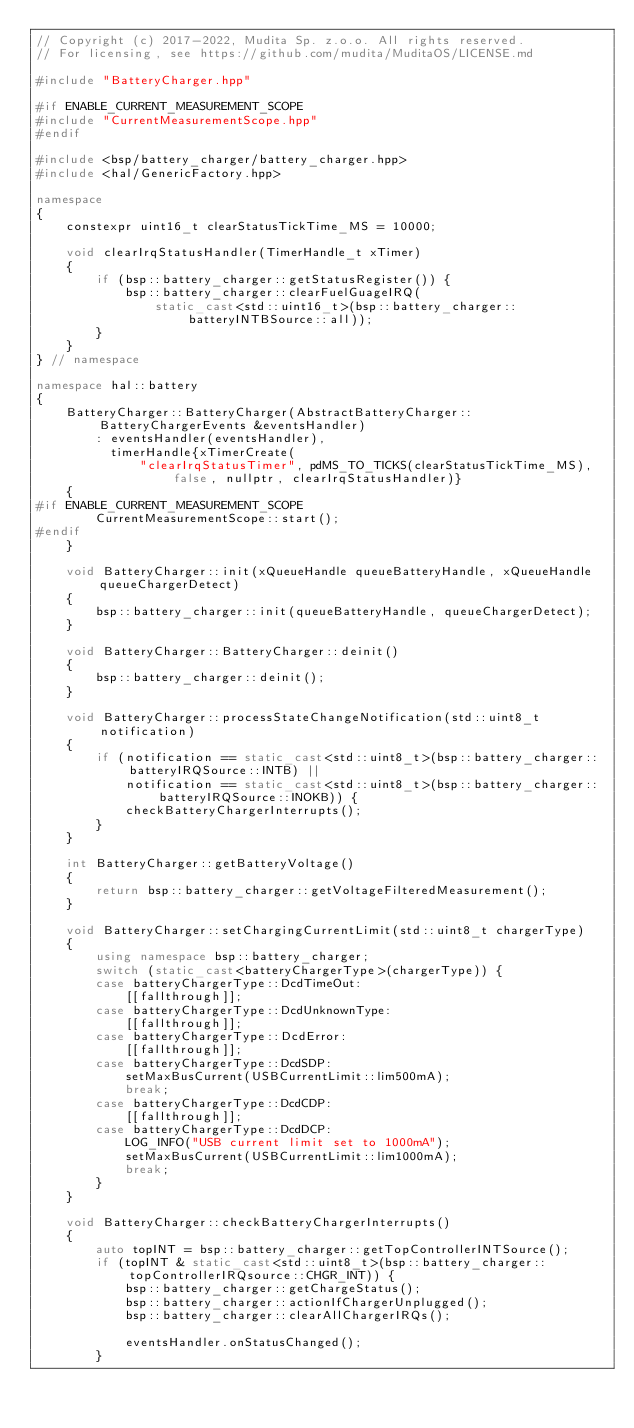Convert code to text. <code><loc_0><loc_0><loc_500><loc_500><_C++_>// Copyright (c) 2017-2022, Mudita Sp. z.o.o. All rights reserved.
// For licensing, see https://github.com/mudita/MuditaOS/LICENSE.md

#include "BatteryCharger.hpp"

#if ENABLE_CURRENT_MEASUREMENT_SCOPE
#include "CurrentMeasurementScope.hpp"
#endif

#include <bsp/battery_charger/battery_charger.hpp>
#include <hal/GenericFactory.hpp>

namespace
{
    constexpr uint16_t clearStatusTickTime_MS = 10000;

    void clearIrqStatusHandler(TimerHandle_t xTimer)
    {
        if (bsp::battery_charger::getStatusRegister()) {
            bsp::battery_charger::clearFuelGuageIRQ(
                static_cast<std::uint16_t>(bsp::battery_charger::batteryINTBSource::all));
        }
    }
} // namespace

namespace hal::battery
{
    BatteryCharger::BatteryCharger(AbstractBatteryCharger::BatteryChargerEvents &eventsHandler)
        : eventsHandler(eventsHandler),
          timerHandle{xTimerCreate(
              "clearIrqStatusTimer", pdMS_TO_TICKS(clearStatusTickTime_MS), false, nullptr, clearIrqStatusHandler)}
    {
#if ENABLE_CURRENT_MEASUREMENT_SCOPE
        CurrentMeasurementScope::start();
#endif
    }

    void BatteryCharger::init(xQueueHandle queueBatteryHandle, xQueueHandle queueChargerDetect)
    {
        bsp::battery_charger::init(queueBatteryHandle, queueChargerDetect);
    }

    void BatteryCharger::BatteryCharger::deinit()
    {
        bsp::battery_charger::deinit();
    }

    void BatteryCharger::processStateChangeNotification(std::uint8_t notification)
    {
        if (notification == static_cast<std::uint8_t>(bsp::battery_charger::batteryIRQSource::INTB) ||
            notification == static_cast<std::uint8_t>(bsp::battery_charger::batteryIRQSource::INOKB)) {
            checkBatteryChargerInterrupts();
        }
    }

    int BatteryCharger::getBatteryVoltage()
    {
        return bsp::battery_charger::getVoltageFilteredMeasurement();
    }

    void BatteryCharger::setChargingCurrentLimit(std::uint8_t chargerType)
    {
        using namespace bsp::battery_charger;
        switch (static_cast<batteryChargerType>(chargerType)) {
        case batteryChargerType::DcdTimeOut:
            [[fallthrough]];
        case batteryChargerType::DcdUnknownType:
            [[fallthrough]];
        case batteryChargerType::DcdError:
            [[fallthrough]];
        case batteryChargerType::DcdSDP:
            setMaxBusCurrent(USBCurrentLimit::lim500mA);
            break;
        case batteryChargerType::DcdCDP:
            [[fallthrough]];
        case batteryChargerType::DcdDCP:
            LOG_INFO("USB current limit set to 1000mA");
            setMaxBusCurrent(USBCurrentLimit::lim1000mA);
            break;
        }
    }

    void BatteryCharger::checkBatteryChargerInterrupts()
    {
        auto topINT = bsp::battery_charger::getTopControllerINTSource();
        if (topINT & static_cast<std::uint8_t>(bsp::battery_charger::topControllerIRQsource::CHGR_INT)) {
            bsp::battery_charger::getChargeStatus();
            bsp::battery_charger::actionIfChargerUnplugged();
            bsp::battery_charger::clearAllChargerIRQs();

            eventsHandler.onStatusChanged();
        }</code> 